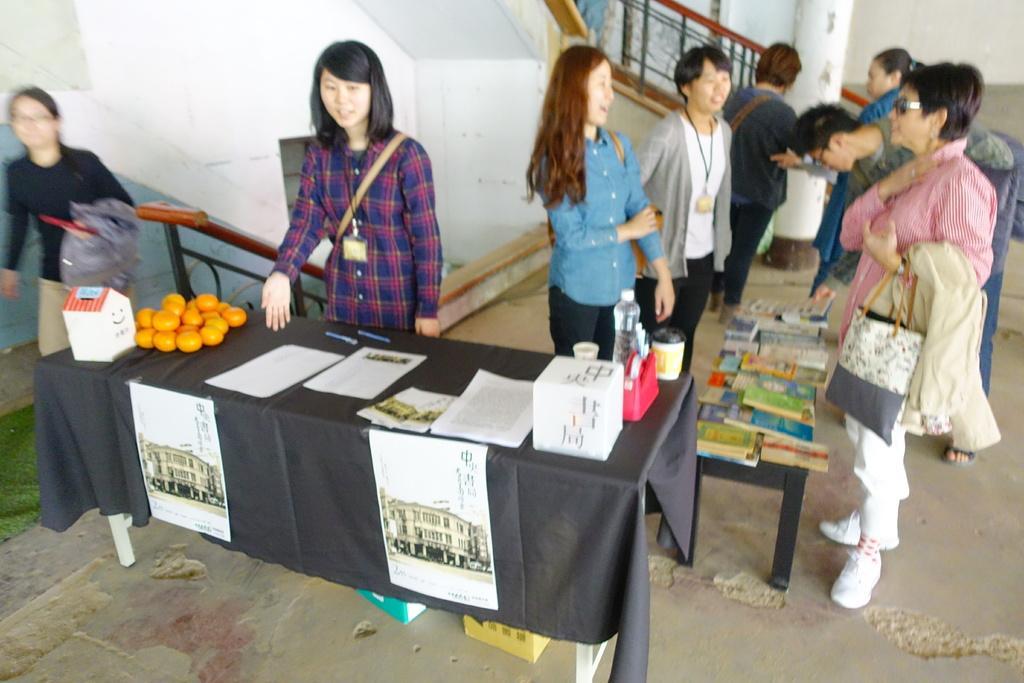Please provide a concise description of this image. In this image I can see number of people are standing. I can also see few of them are wearing ID cards. Here on this table I can see few papers, a box and a water bottle. Here I can see she is carrying a handbag. 